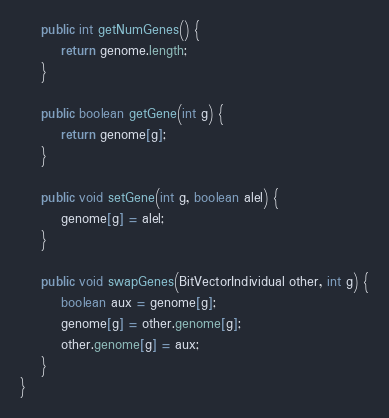Convert code to text. <code><loc_0><loc_0><loc_500><loc_500><_Java_>    public int getNumGenes() {
        return genome.length;
    }

    public boolean getGene(int g) {
        return genome[g];
    }

    public void setGene(int g, boolean alel) {
        genome[g] = alel;
    }

    public void swapGenes(BitVectorIndividual other, int g) {
        boolean aux = genome[g];
        genome[g] = other.genome[g];
        other.genome[g] = aux;
    }
}
</code> 